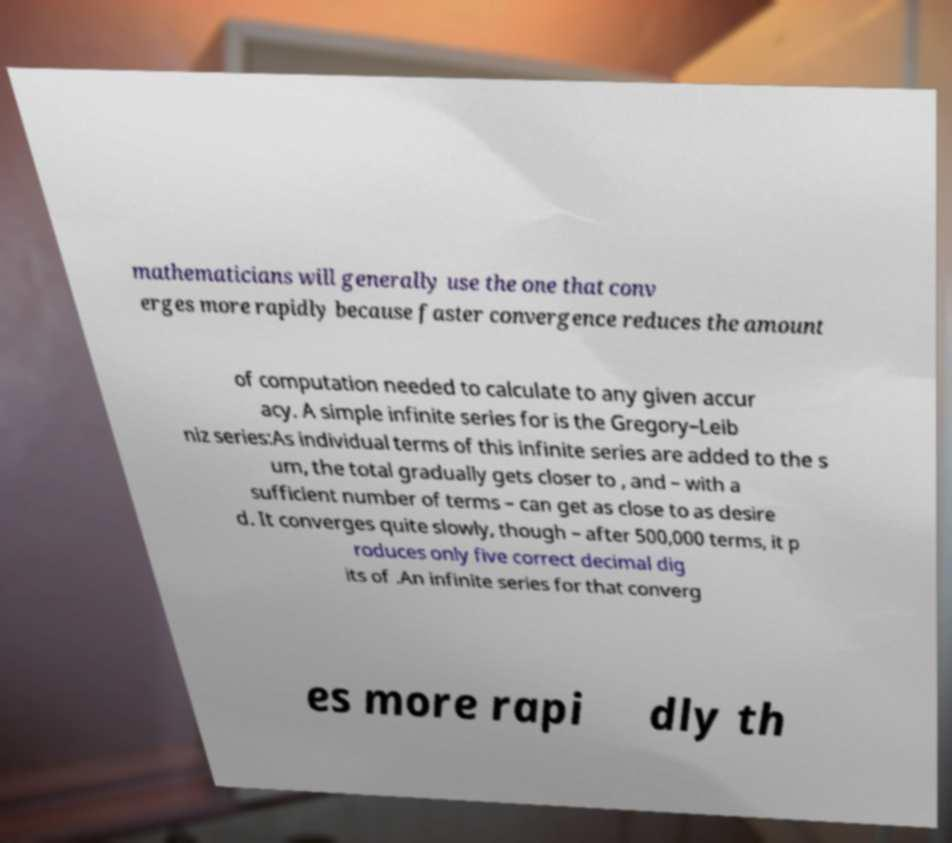I need the written content from this picture converted into text. Can you do that? mathematicians will generally use the one that conv erges more rapidly because faster convergence reduces the amount of computation needed to calculate to any given accur acy. A simple infinite series for is the Gregory–Leib niz series:As individual terms of this infinite series are added to the s um, the total gradually gets closer to , and – with a sufficient number of terms – can get as close to as desire d. It converges quite slowly, though – after 500,000 terms, it p roduces only five correct decimal dig its of .An infinite series for that converg es more rapi dly th 